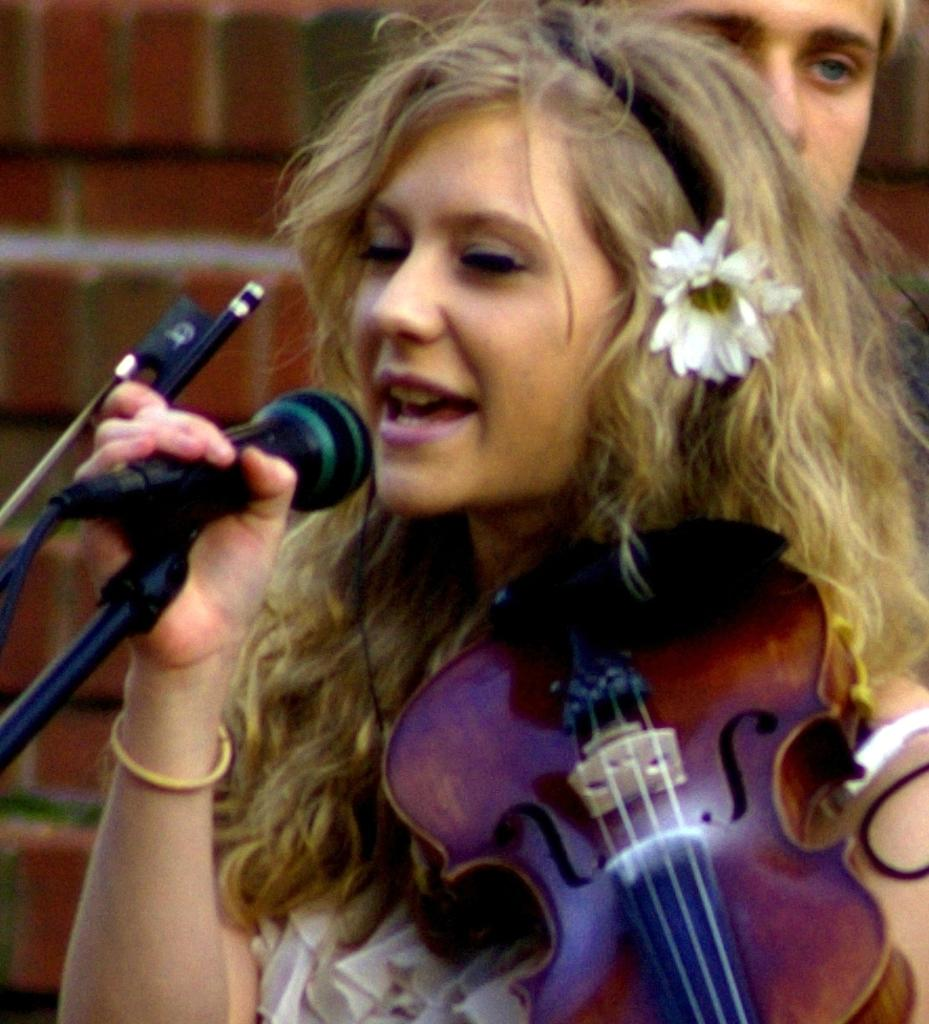What is the woman in the image doing? The woman is singing and holding a musical instrument. What object is the woman holding in her hand? The woman is holding a microphone. Is there anyone else in the image besides the woman? Yes, there is a man in the image. What type of spade is the woman using to play the musical instrument in the image? There is no spade present in the image, and the woman is not using any tool to play the musical instrument. 